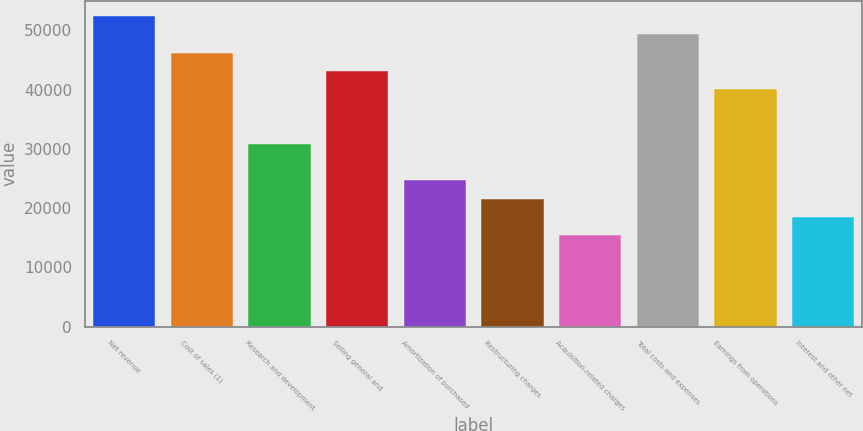Convert chart to OTSL. <chart><loc_0><loc_0><loc_500><loc_500><bar_chart><fcel>Net revenue<fcel>Cost of sales (1)<fcel>Research and development<fcel>Selling general and<fcel>Amortization of purchased<fcel>Restructuring charges<fcel>Acquisition-related charges<fcel>Total costs and expenses<fcel>Earnings from operations<fcel>Interest and other net<nl><fcel>52443.2<fcel>46273.4<fcel>30849<fcel>43188.5<fcel>24679.2<fcel>21594.3<fcel>15424.5<fcel>49358.3<fcel>40103.7<fcel>18509.4<nl></chart> 